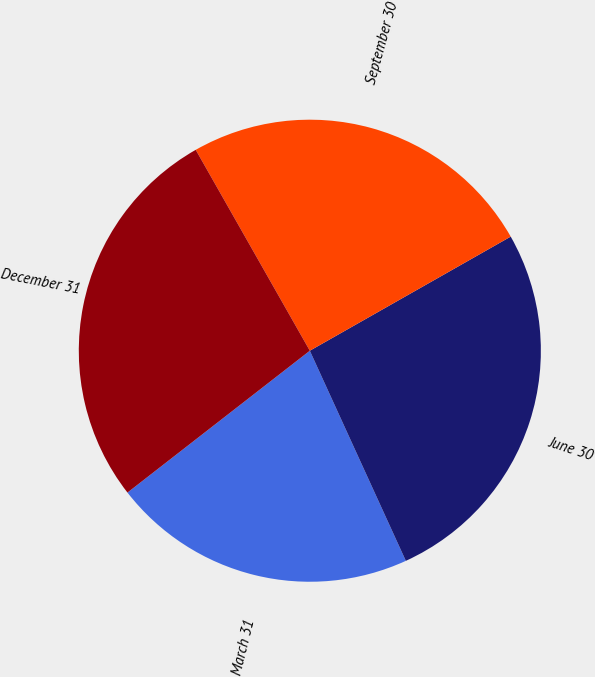Convert chart. <chart><loc_0><loc_0><loc_500><loc_500><pie_chart><fcel>March 31<fcel>June 30<fcel>September 30<fcel>December 31<nl><fcel>21.3%<fcel>26.4%<fcel>25.0%<fcel>27.3%<nl></chart> 